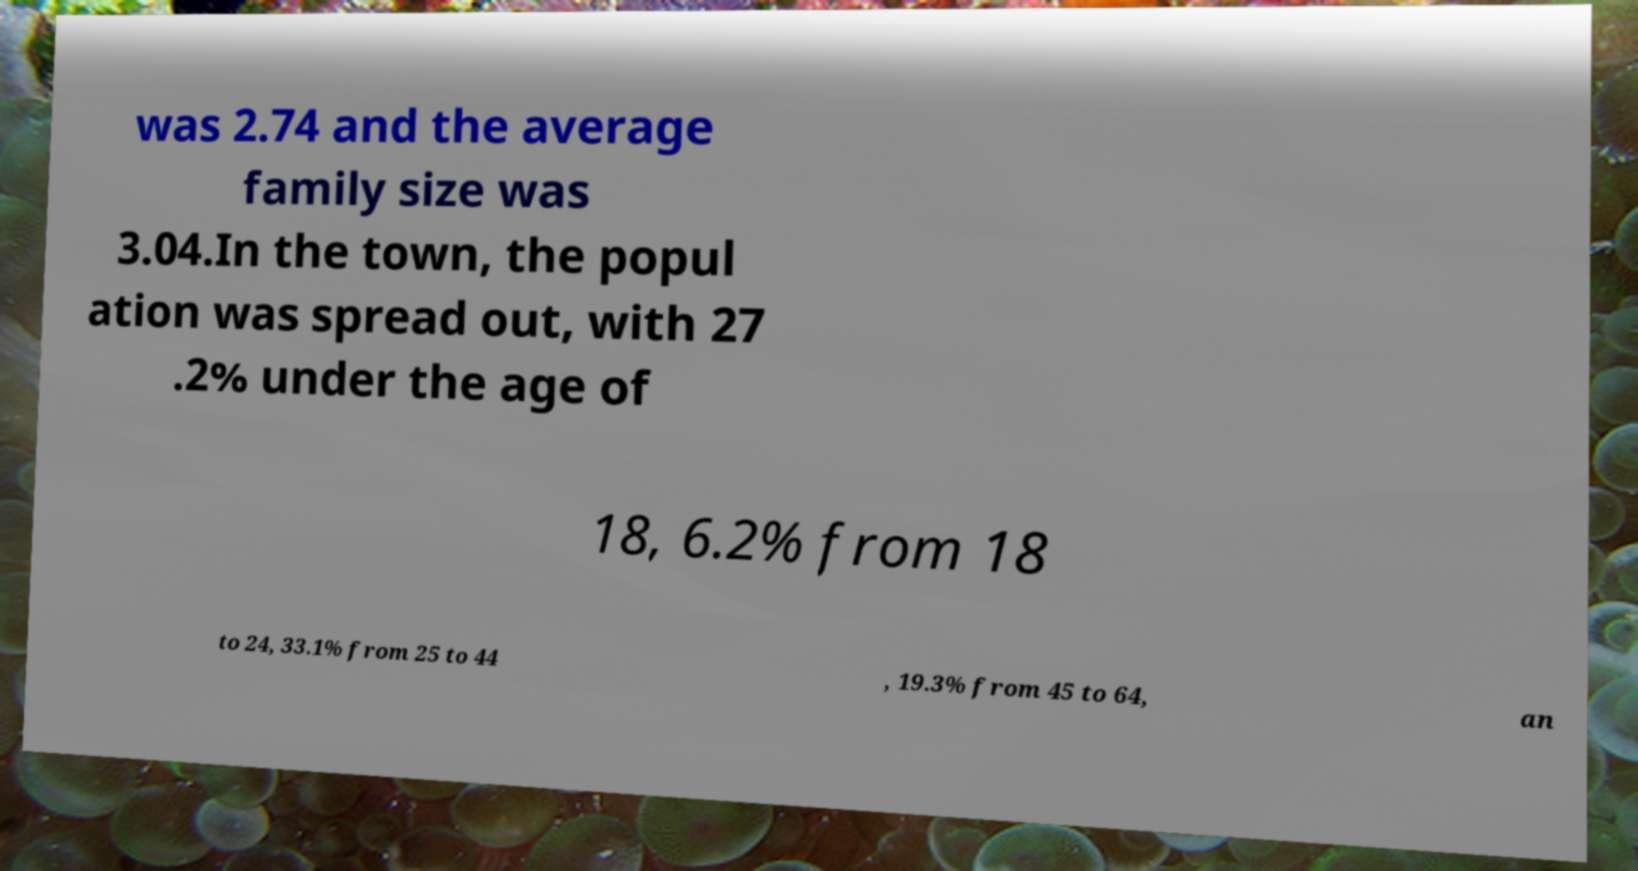What messages or text are displayed in this image? I need them in a readable, typed format. was 2.74 and the average family size was 3.04.In the town, the popul ation was spread out, with 27 .2% under the age of 18, 6.2% from 18 to 24, 33.1% from 25 to 44 , 19.3% from 45 to 64, an 